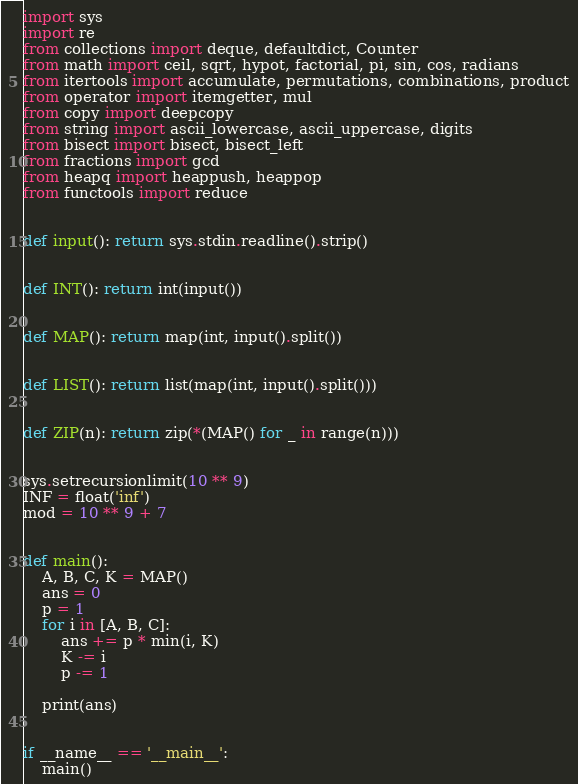<code> <loc_0><loc_0><loc_500><loc_500><_Python_>import sys
import re
from collections import deque, defaultdict, Counter
from math import ceil, sqrt, hypot, factorial, pi, sin, cos, radians
from itertools import accumulate, permutations, combinations, product
from operator import itemgetter, mul
from copy import deepcopy
from string import ascii_lowercase, ascii_uppercase, digits
from bisect import bisect, bisect_left
from fractions import gcd
from heapq import heappush, heappop
from functools import reduce


def input(): return sys.stdin.readline().strip()


def INT(): return int(input())


def MAP(): return map(int, input().split())


def LIST(): return list(map(int, input().split()))


def ZIP(n): return zip(*(MAP() for _ in range(n)))


sys.setrecursionlimit(10 ** 9)
INF = float('inf')
mod = 10 ** 9 + 7


def main():
    A, B, C, K = MAP()
    ans = 0
    p = 1
    for i in [A, B, C]:
        ans += p * min(i, K)
        K -= i
        p -= 1

    print(ans)


if __name__ == '__main__':
    main()
</code> 